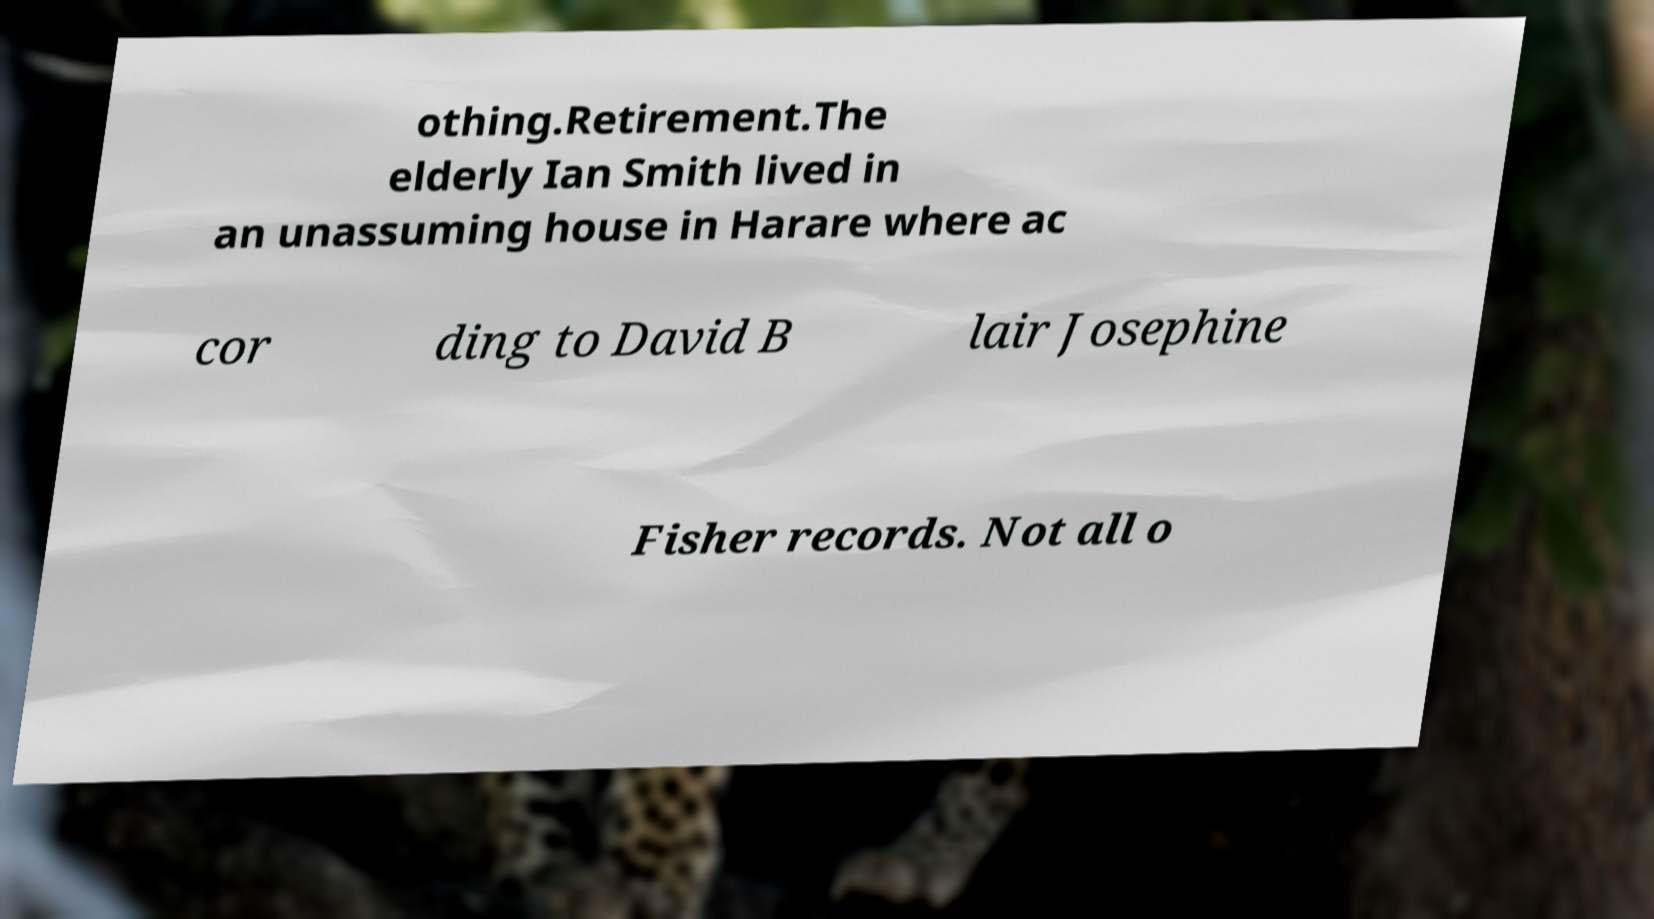Can you accurately transcribe the text from the provided image for me? othing.Retirement.The elderly Ian Smith lived in an unassuming house in Harare where ac cor ding to David B lair Josephine Fisher records. Not all o 